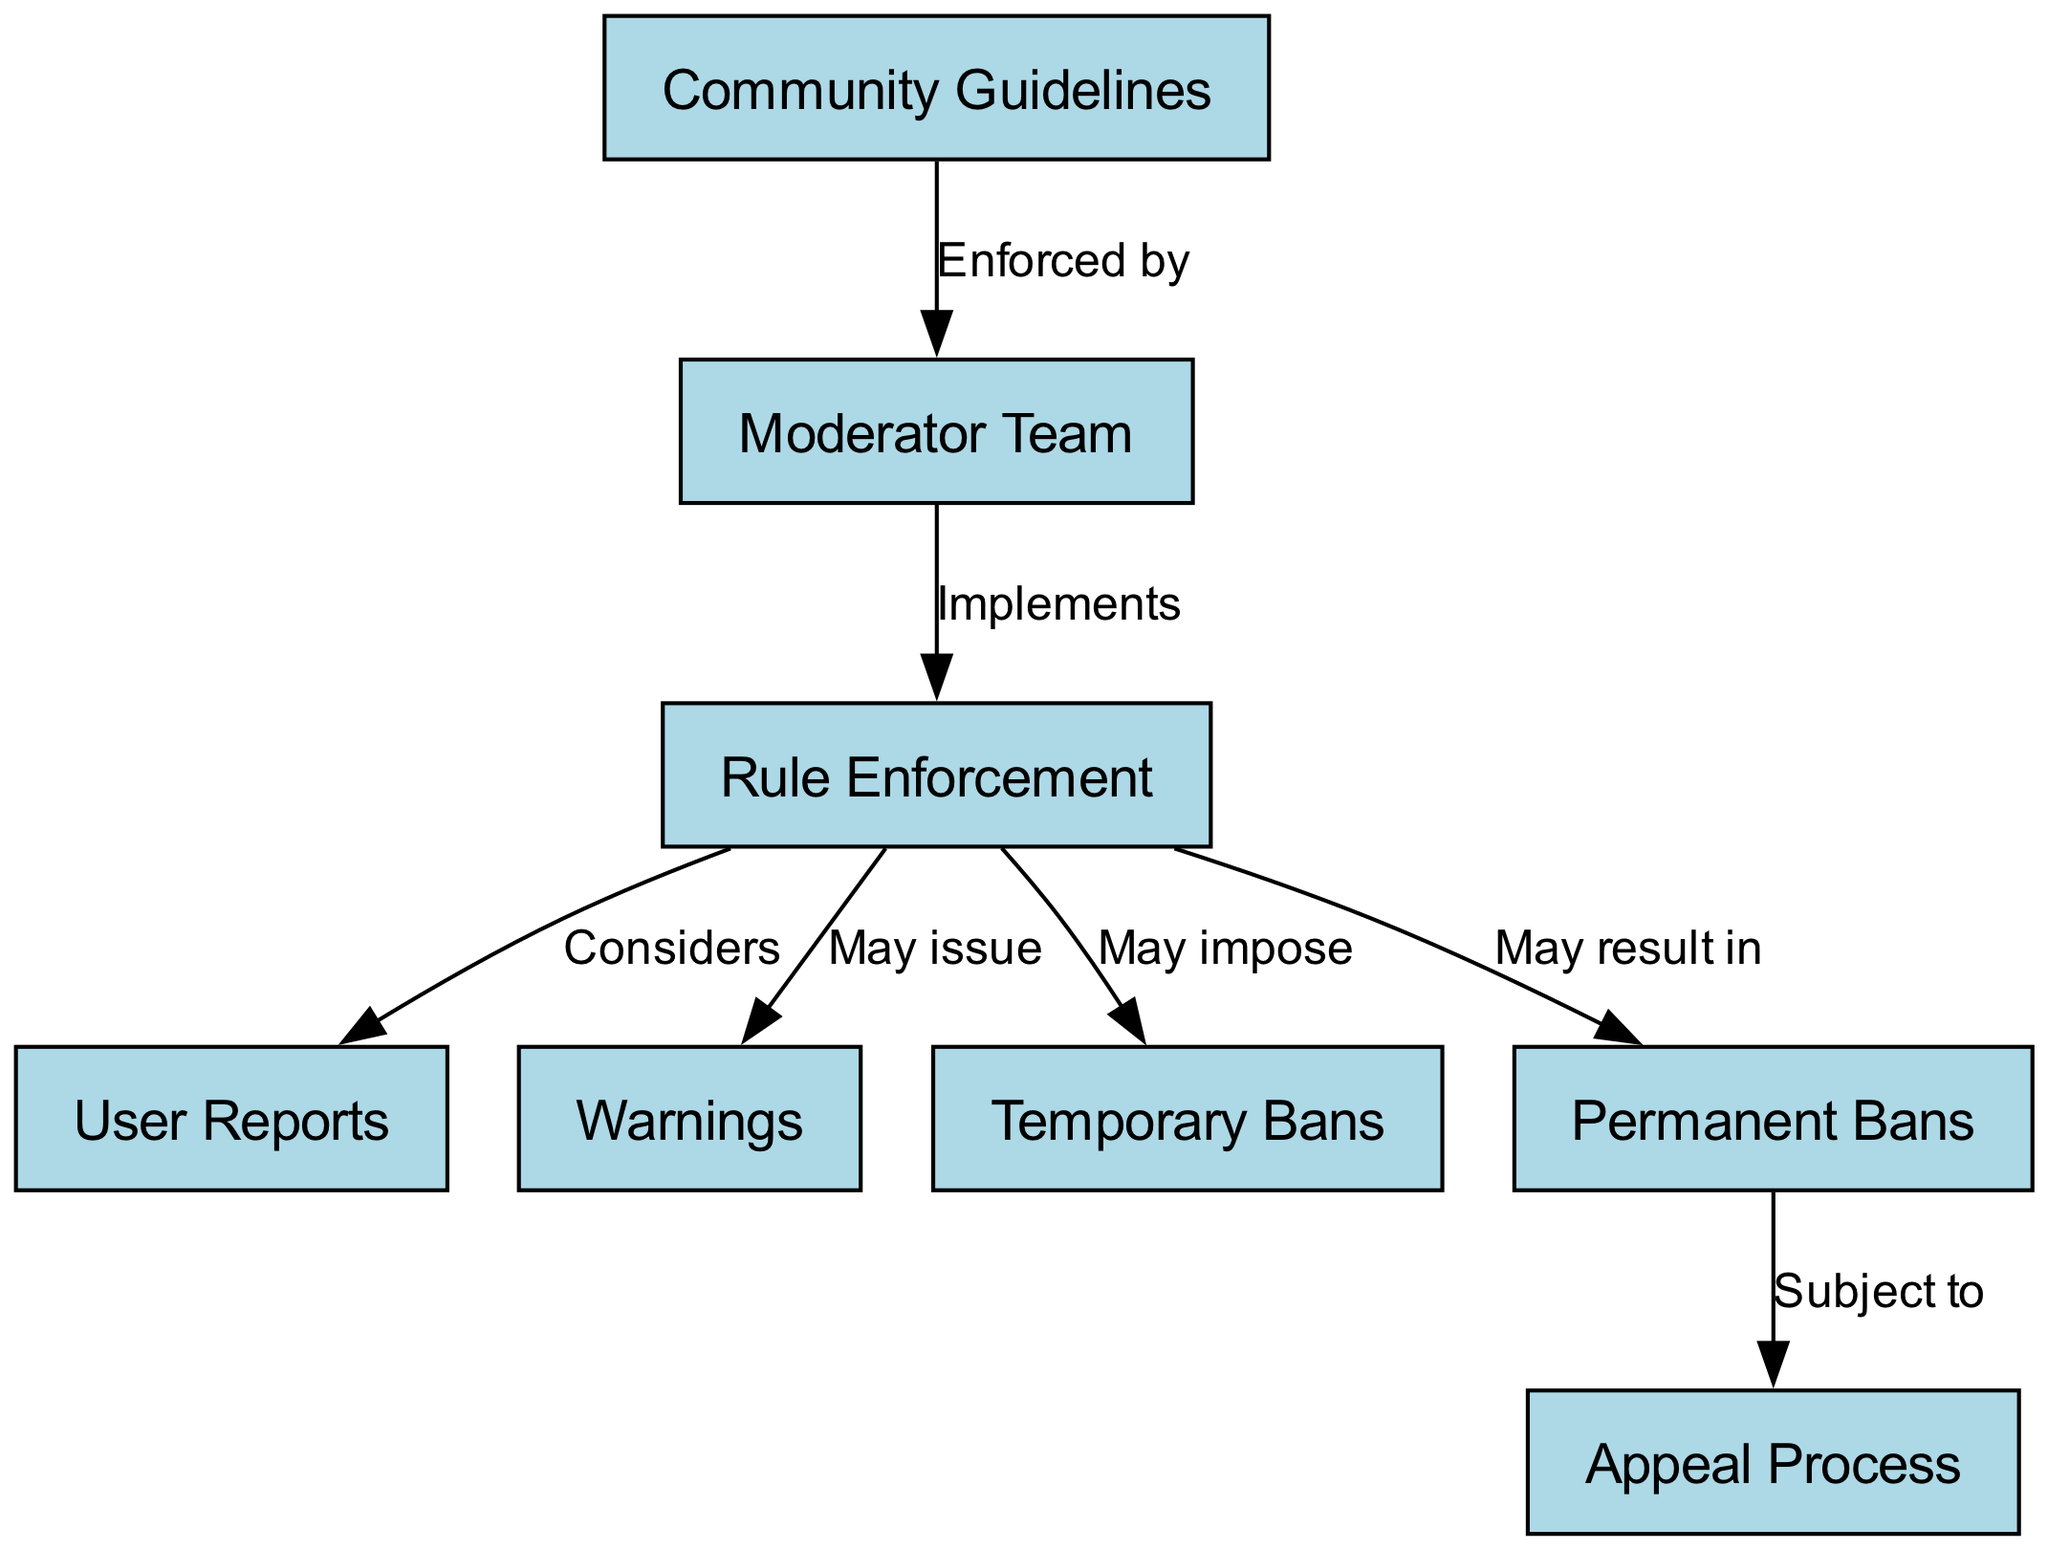What is the primary entity that the Moderator Team enforces? The Moderator Team enforces the Community Guidelines, as indicated by the edge labeled "Enforced by" between the nodes for Community Guidelines and Moderator Team.
Answer: Community Guidelines How many nodes are represented in the diagram? The diagram contains eight nodes, each representing different concepts related to community guidelines and rule enforcement.
Answer: 8 What action may result in a Permanent Ban? A Permanent Ban may result from the Rule Enforcement process, as shown by the edge labeled "May result in" connecting Rule Enforcement to Permanent Bans.
Answer: Permanent Ban Which node does the User Reports connect to, and what is the relationship? User Reports connect to Rule Enforcement through the edge labeled "Considers," indicating that Rule Enforcement takes User Reports into account.
Answer: Considers What is the relationship between Permanent Bans and the Appeal Process? The relationship between Permanent Bans and the Appeal Process is that Permanent Bans are subject to an appeal process, shown by the edge labeled "Subject to" connecting these two nodes.
Answer: Subject to What follows the issuing of Warnings in the Rule Enforcement process? The Rule Enforcement process may issue Warnings, and this is a potential action indicated by the edge labeled "May issue" connecting Rule Enforcement and Warnings, suggesting it is a possible next step.
Answer: May issue What does the Moderator Team implement according to the diagram? According to the diagram, the Moderator Team implements Rule Enforcement, indicated by the edge labeled "Implements" connecting Moderator Team and Rule Enforcement.
Answer: Rule Enforcement What does Rule Enforcement consider according to the diagram? Rule Enforcement considers User Reports, as indicated by the edge labeled "Considers" connecting Rule Enforcement to User Reports.
Answer: User Reports 